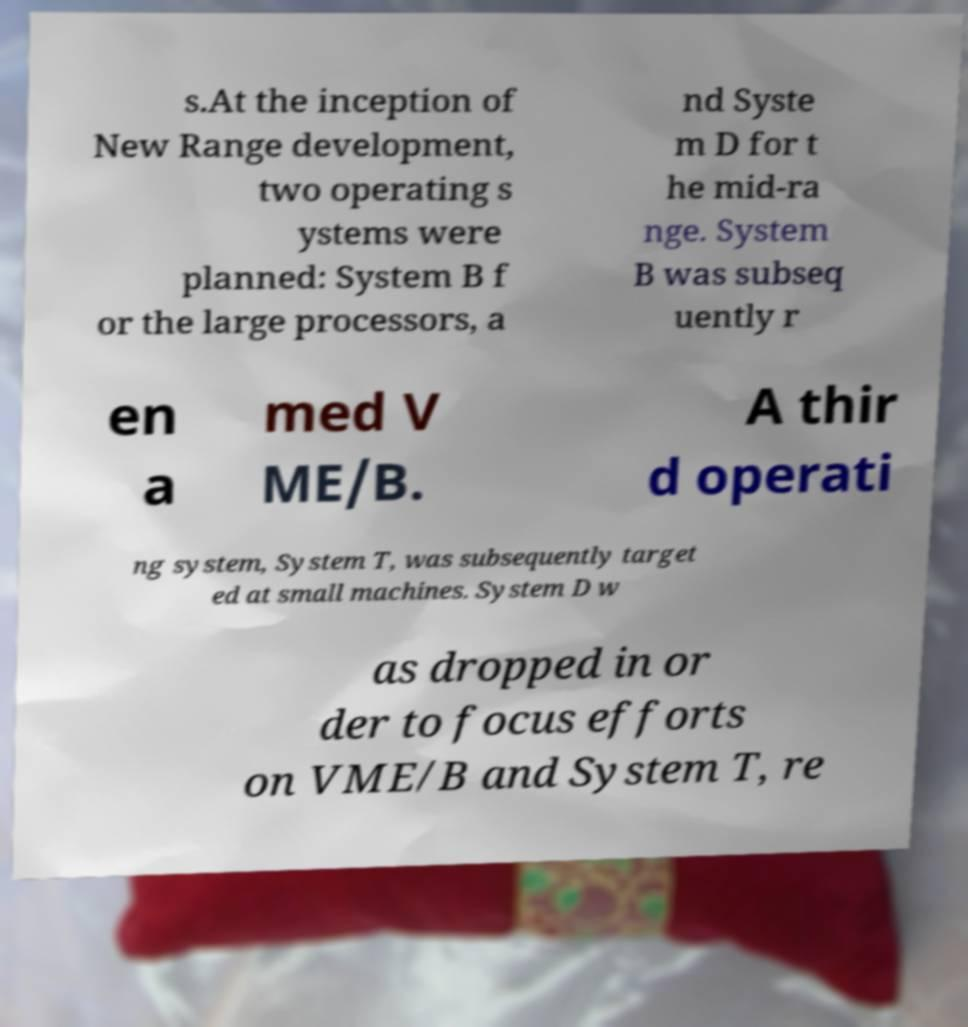Could you assist in decoding the text presented in this image and type it out clearly? s.At the inception of New Range development, two operating s ystems were planned: System B f or the large processors, a nd Syste m D for t he mid-ra nge. System B was subseq uently r en a med V ME/B. A thir d operati ng system, System T, was subsequently target ed at small machines. System D w as dropped in or der to focus efforts on VME/B and System T, re 